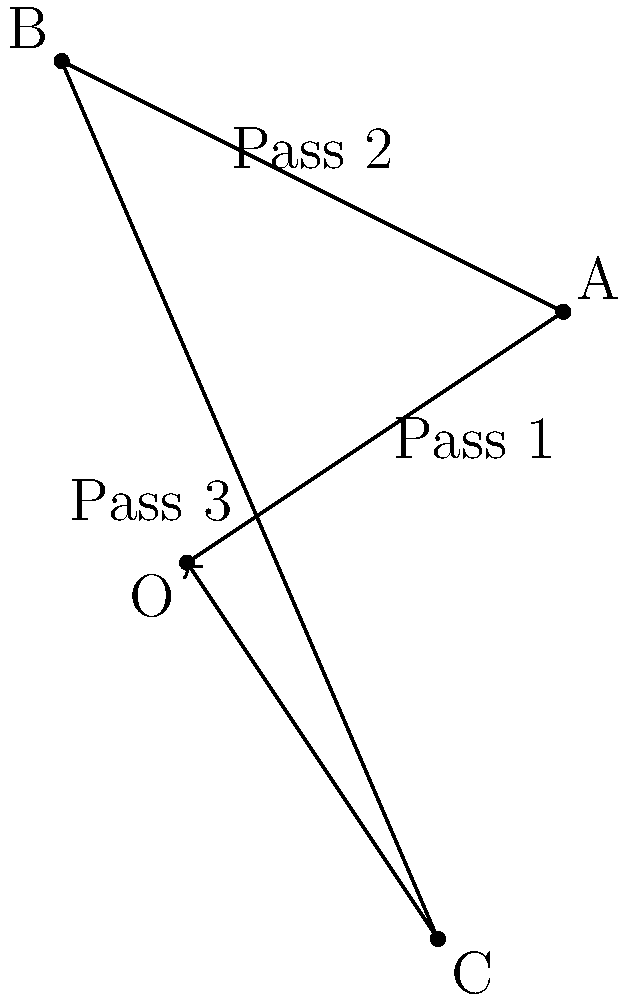In a memorable match from your playing days, you initiated a series of passes on the soccer field. The first pass moved the ball 3 units east and 2 units north. The second pass then moved it 4 units west and 2 units north. The final pass moved the ball 3 units east and 7 units south. What was the ball's final position relative to its starting point? Let's approach this step-by-step using vector addition:

1) First, we'll represent each pass as a vector:
   Pass 1: $\vec{v_1} = (3, 2)$
   Pass 2: $\vec{v_2} = (-4, 2)$
   Pass 3: $\vec{v_3} = (3, -7)$

2) To find the final position, we need to add these vectors:
   $\vec{v_{final}} = \vec{v_1} + \vec{v_2} + \vec{v_3}$

3) Let's add the x-components:
   $x_{final} = 3 + (-4) + 3 = 2$

4) Now, let's add the y-components:
   $y_{final} = 2 + 2 + (-7) = -3$

5) Therefore, the final position vector is:
   $\vec{v_{final}} = (2, -3)$

This means the ball ended up 2 units east and 3 units south of its starting position.
Answer: (2, -3) 